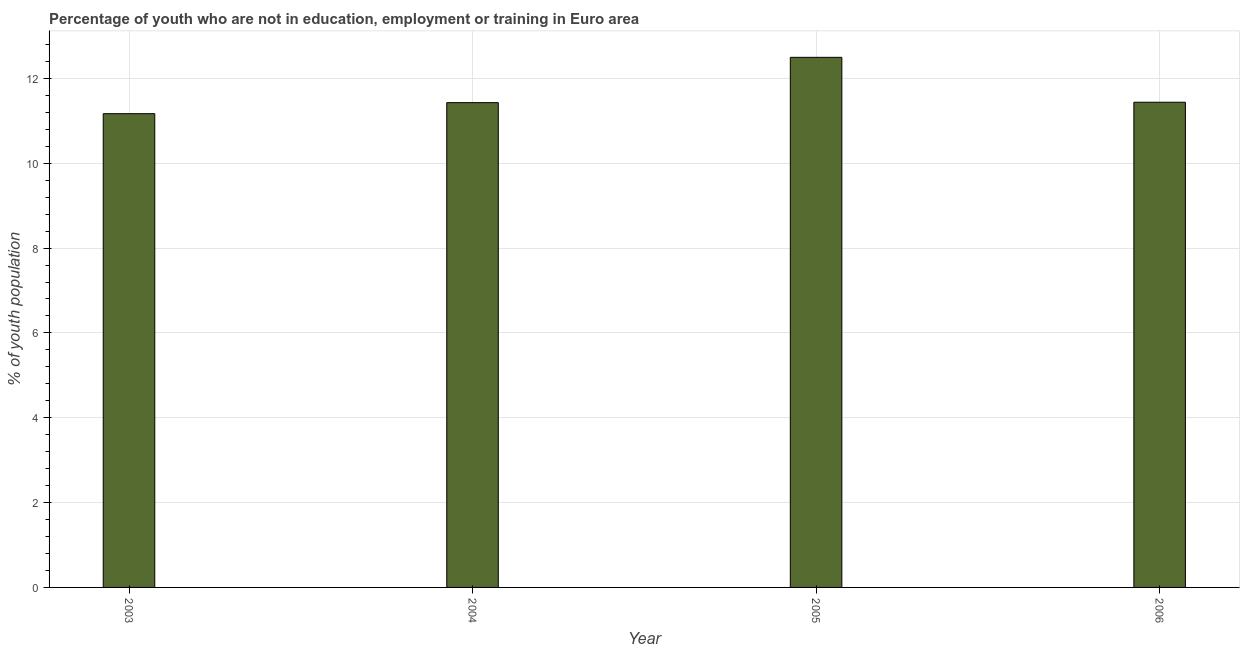Does the graph contain any zero values?
Ensure brevity in your answer.  No. What is the title of the graph?
Ensure brevity in your answer.  Percentage of youth who are not in education, employment or training in Euro area. What is the label or title of the X-axis?
Ensure brevity in your answer.  Year. What is the label or title of the Y-axis?
Ensure brevity in your answer.  % of youth population. What is the unemployed youth population in 2004?
Your answer should be compact. 11.43. Across all years, what is the maximum unemployed youth population?
Ensure brevity in your answer.  12.5. Across all years, what is the minimum unemployed youth population?
Give a very brief answer. 11.17. What is the sum of the unemployed youth population?
Keep it short and to the point. 46.53. What is the difference between the unemployed youth population in 2004 and 2006?
Make the answer very short. -0.01. What is the average unemployed youth population per year?
Your response must be concise. 11.63. What is the median unemployed youth population?
Provide a short and direct response. 11.43. Do a majority of the years between 2006 and 2004 (inclusive) have unemployed youth population greater than 11.2 %?
Offer a terse response. Yes. What is the difference between the highest and the second highest unemployed youth population?
Keep it short and to the point. 1.06. What is the difference between the highest and the lowest unemployed youth population?
Your answer should be compact. 1.33. In how many years, is the unemployed youth population greater than the average unemployed youth population taken over all years?
Your answer should be very brief. 1. How many bars are there?
Your answer should be compact. 4. What is the difference between two consecutive major ticks on the Y-axis?
Provide a succinct answer. 2. Are the values on the major ticks of Y-axis written in scientific E-notation?
Give a very brief answer. No. What is the % of youth population in 2003?
Make the answer very short. 11.17. What is the % of youth population of 2004?
Your answer should be very brief. 11.43. What is the % of youth population of 2005?
Your answer should be compact. 12.5. What is the % of youth population in 2006?
Ensure brevity in your answer.  11.44. What is the difference between the % of youth population in 2003 and 2004?
Ensure brevity in your answer.  -0.26. What is the difference between the % of youth population in 2003 and 2005?
Offer a very short reply. -1.33. What is the difference between the % of youth population in 2003 and 2006?
Offer a very short reply. -0.27. What is the difference between the % of youth population in 2004 and 2005?
Provide a short and direct response. -1.07. What is the difference between the % of youth population in 2004 and 2006?
Provide a short and direct response. -0.01. What is the difference between the % of youth population in 2005 and 2006?
Give a very brief answer. 1.06. What is the ratio of the % of youth population in 2003 to that in 2004?
Keep it short and to the point. 0.98. What is the ratio of the % of youth population in 2003 to that in 2005?
Your response must be concise. 0.89. What is the ratio of the % of youth population in 2003 to that in 2006?
Your response must be concise. 0.98. What is the ratio of the % of youth population in 2004 to that in 2005?
Your answer should be compact. 0.92. What is the ratio of the % of youth population in 2004 to that in 2006?
Give a very brief answer. 1. What is the ratio of the % of youth population in 2005 to that in 2006?
Keep it short and to the point. 1.09. 